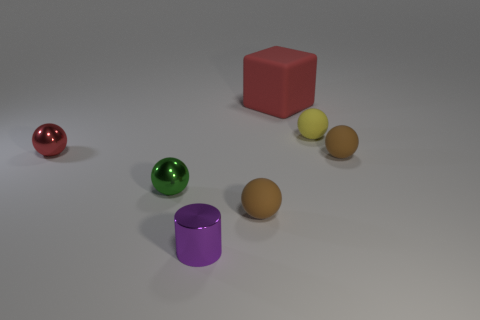Can you tell me what the green object on the left is? The green object appears to be a shiny, reflective sphere, probably made of glass or a polished metal, given the reflections you can see on its surface. 